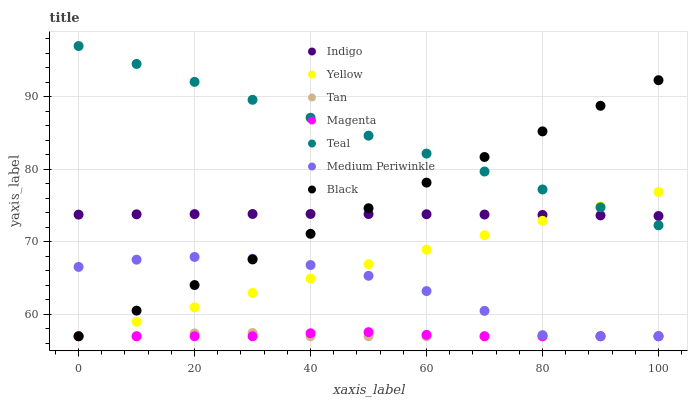Does Tan have the minimum area under the curve?
Answer yes or no. Yes. Does Teal have the maximum area under the curve?
Answer yes or no. Yes. Does Medium Periwinkle have the minimum area under the curve?
Answer yes or no. No. Does Medium Periwinkle have the maximum area under the curve?
Answer yes or no. No. Is Yellow the smoothest?
Answer yes or no. Yes. Is Medium Periwinkle the roughest?
Answer yes or no. Yes. Is Medium Periwinkle the smoothest?
Answer yes or no. No. Is Yellow the roughest?
Answer yes or no. No. Does Medium Periwinkle have the lowest value?
Answer yes or no. Yes. Does Teal have the lowest value?
Answer yes or no. No. Does Teal have the highest value?
Answer yes or no. Yes. Does Medium Periwinkle have the highest value?
Answer yes or no. No. Is Tan less than Teal?
Answer yes or no. Yes. Is Indigo greater than Medium Periwinkle?
Answer yes or no. Yes. Does Medium Periwinkle intersect Black?
Answer yes or no. Yes. Is Medium Periwinkle less than Black?
Answer yes or no. No. Is Medium Periwinkle greater than Black?
Answer yes or no. No. Does Tan intersect Teal?
Answer yes or no. No. 